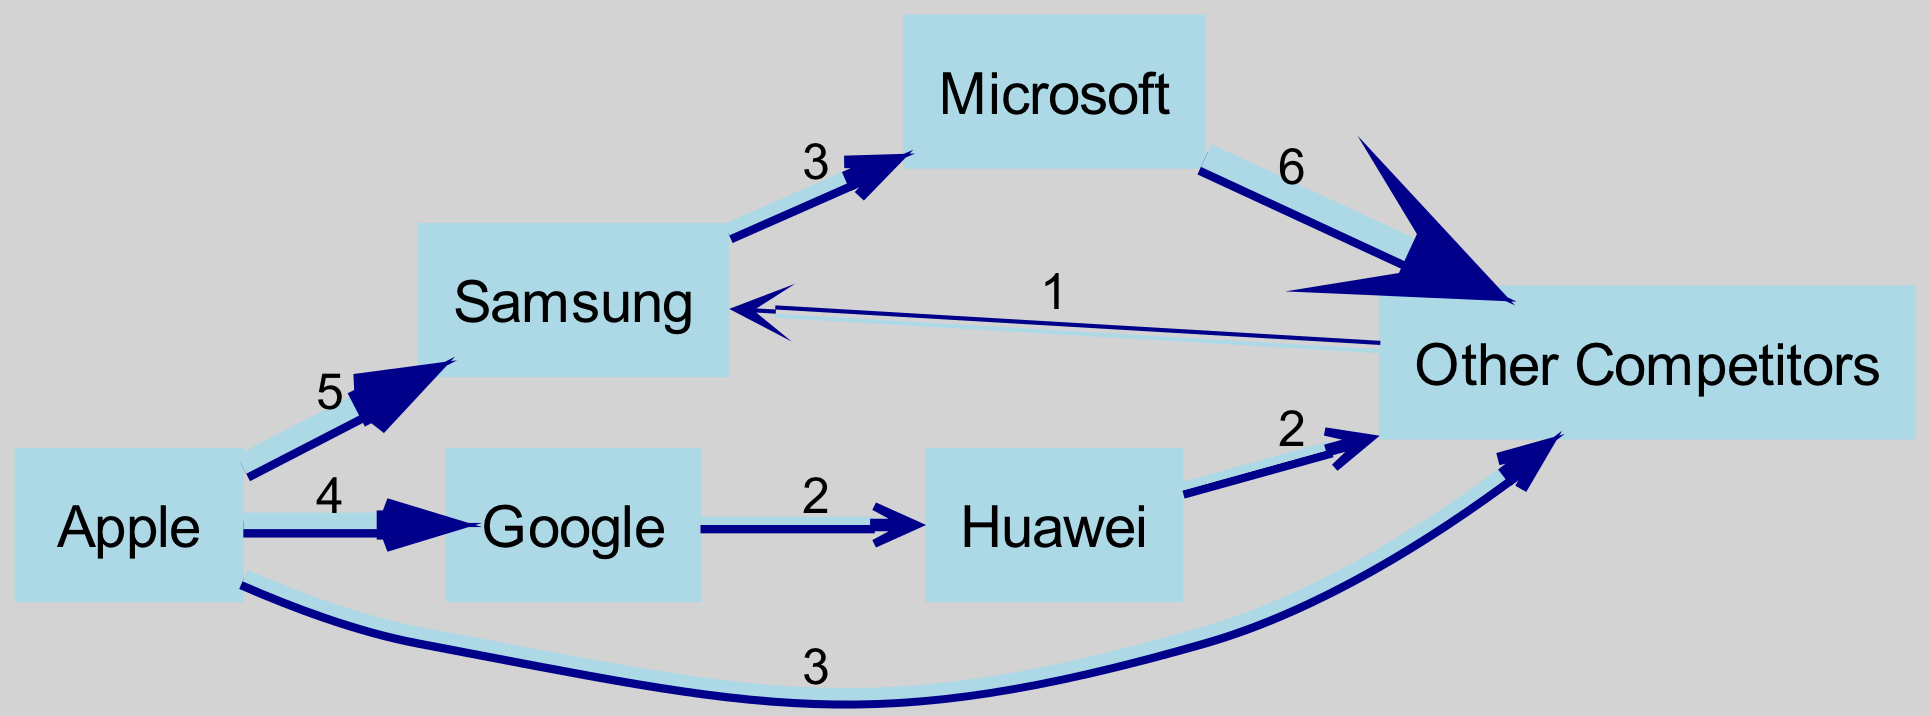What is the total number of nodes represented in the diagram? Counting the unique entities shown in the diagram, we identify six nodes: Apple, Samsung, Microsoft, Google, Huawei, and Other Competitors.
Answer: 6 What are the competitors that Apple impacts directly in the diagram? Tracing the edges emanating from Apple, we find it directly influences Samsung (5), Google (4), and Other Competitors (3).
Answer: Samsung, Google, Other Competitors How many total units of market share flow from Samsung to Microsoft? Following the link from Samsung to Microsoft, the diagram indicates a flow of 3 units.
Answer: 3 Which company received the most flow from Apple? Reviewing the flow from Apple, we see that it flows the most to Samsung, with 5 units, compared to 4 units to Google and 3 to Other Competitors.
Answer: Samsung What is the total market share flow towards Other Competitors? Analyzing the flow to Other Competitors, we see it receives 6 from Microsoft, 2 from Huawei, and 3 from Apple, summing to 11 in total.
Answer: 11 Which competitor loses the most market share to Other Competitors? Investigating the flow structure, Microsoft loses the largest flow of 6 units directly to Other Competitors, more than any other competitor in the diagram.
Answer: Microsoft How many links exist in the diagram? By counting the connecting edges in the diagram that illustrate the flows between companies, we find a total of 8 links.
Answer: 8 What percentage of flows from Apple go to Other Competitors compared to Samsung? The total flows from Apple are 5 to Samsung, 4 to Google, and 3 to Other Competitors. Therefore, the percentage to Other Competitors is (3 out of 12 total) which is 25%, while for Samsung it is (5 out of 12) which is approximately 41.67%.
Answer: 25%, 41.67% Which node has no outgoing flows? Reviewing the outgoing edges from each node, we determine that 'Other Competitors' does not send any flows to other entities in the diagram.
Answer: Other Competitors 